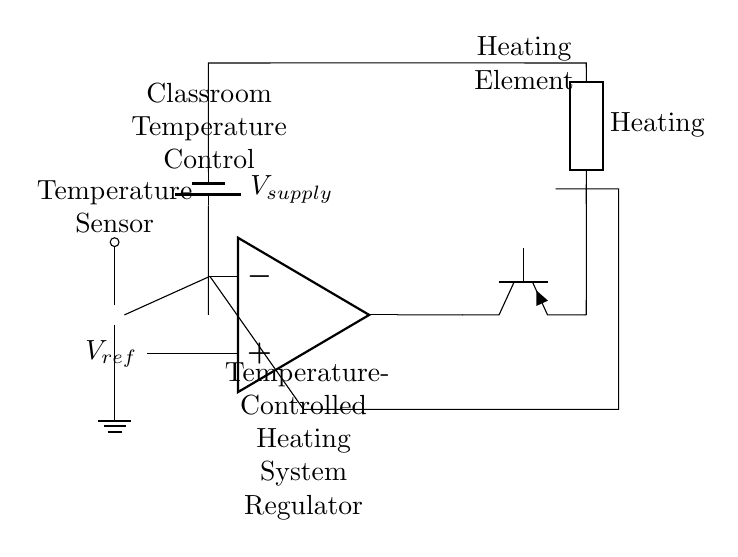What component senses temperature? The temperature sensor is represented by the thermistor in the circuit, which detects changes in temperature.
Answer: thermistor What does the op amp do in this circuit? The op amp compares the voltage from the thermistor with a reference voltage to control the heating element based on temperature readings.
Answer: compare voltage How is the heating element powered? The heating element is powered by a supply voltage drawn from the battery in the circuit.
Answer: battery supply What type of transistor is used for the heating element control? The circuit uses a PNP transistor to control the current flow to the heating element based on the op amp output.
Answer: PNP What is the purpose of the feedback loop in this circuit? The feedback loop allows the op amp to adjust its output based on the temperature detected, helping to maintain a desired temperature.
Answer: maintain temperature What is the role of the reference voltage in the circuit? The reference voltage sets the temperature set point against which the thermistor's voltage is compared to determine if heating is necessary.
Answer: set point What component connects the thermistor to the op amp? A short connection wire is used to link the thermistor's output to the inverting input of the op amp for voltage comparison.
Answer: connection wire 